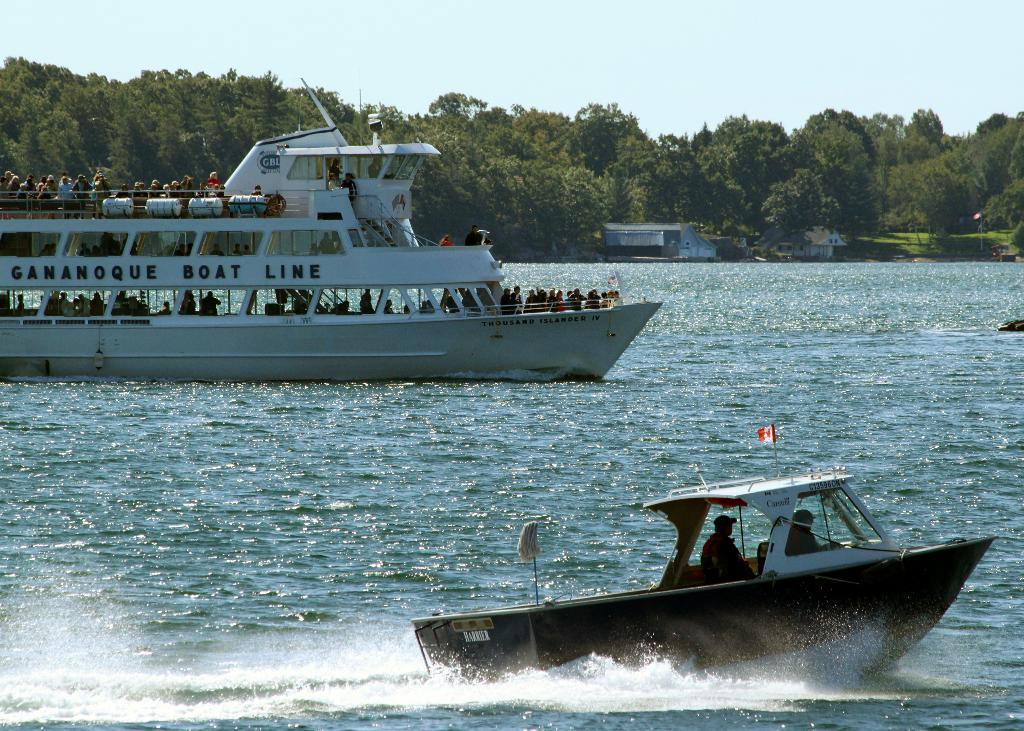What type of vehicles are above the water in the image? There are ships above the water in the image. Who is present in the ships? People are present in the ships. What can be seen in the background of the image? There are trees, houses, grass, and the sky visible in the background of the image. What type of juice is being served in the box on the ship? There is no juice or box present in the image; it only features ships, people, and the background elements. 